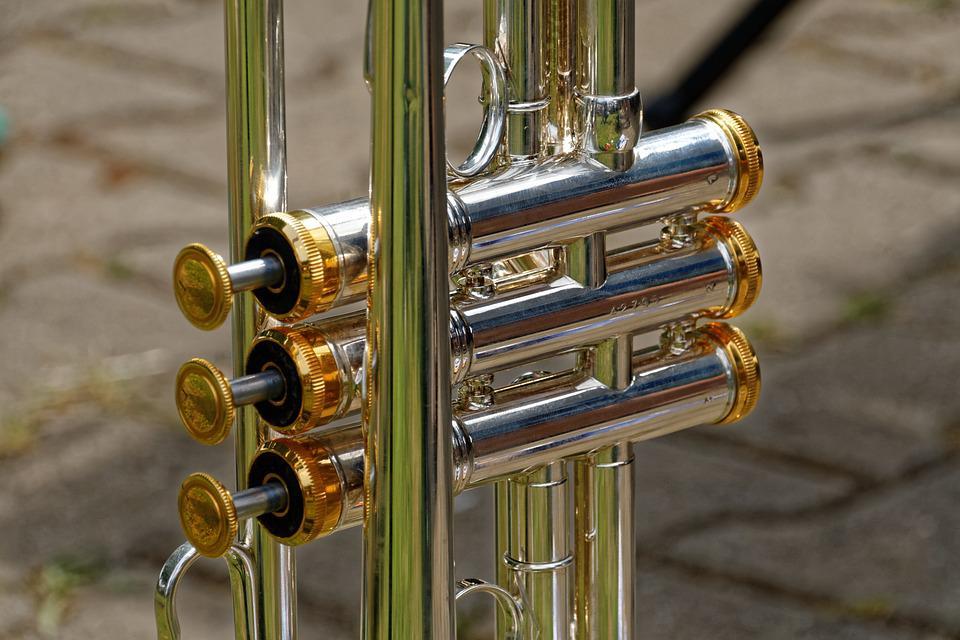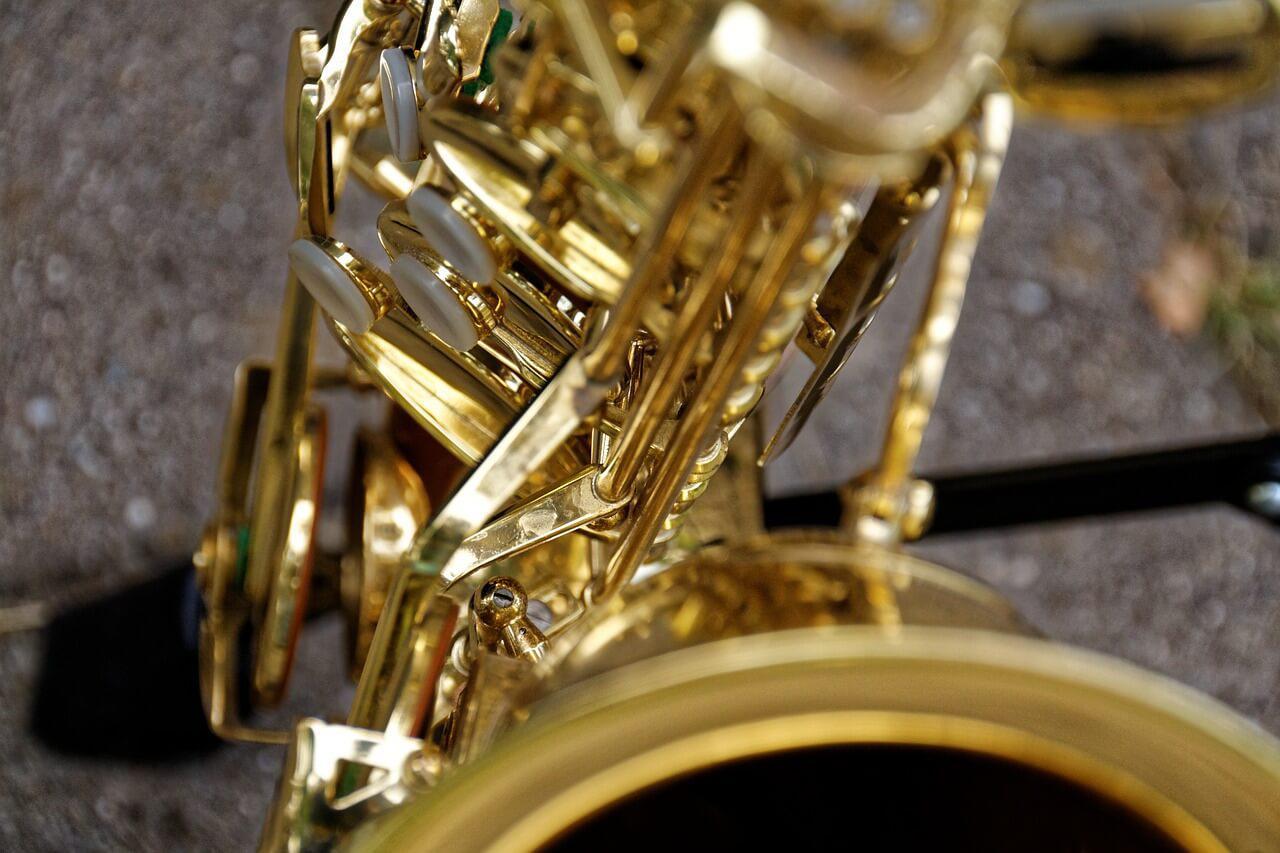The first image is the image on the left, the second image is the image on the right. Assess this claim about the two images: "At least two intact brass-colored saxophones are displayed with the bell facing rightward.". Correct or not? Answer yes or no. No. 